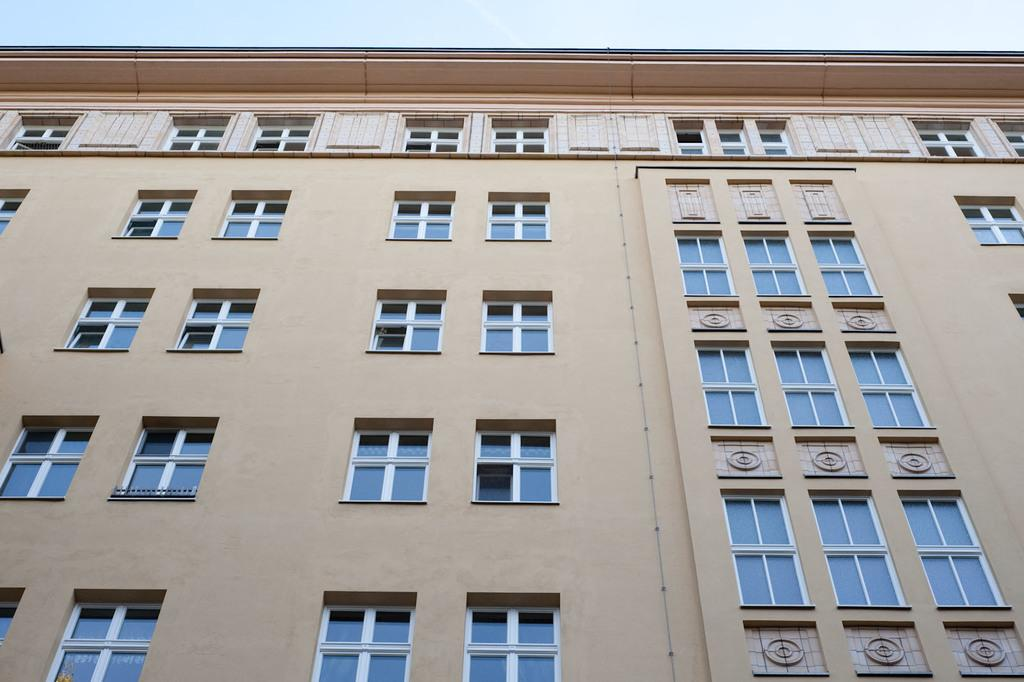What type of structure is present in the image? There is a building in the image. What colors are used on the building? The building has light grey and light pink colors. What feature is prominently visible on the building? The building has many glass windows. What is visible at the top of the image? The sky is visible at the top of the image. Can you see a snail crawling on the building in the image? There is no snail present on the building in the image. What season is it in the image, considering the colors of the building? The colors of the building do not indicate a specific season, as light grey and light pink can be used in various seasons. 